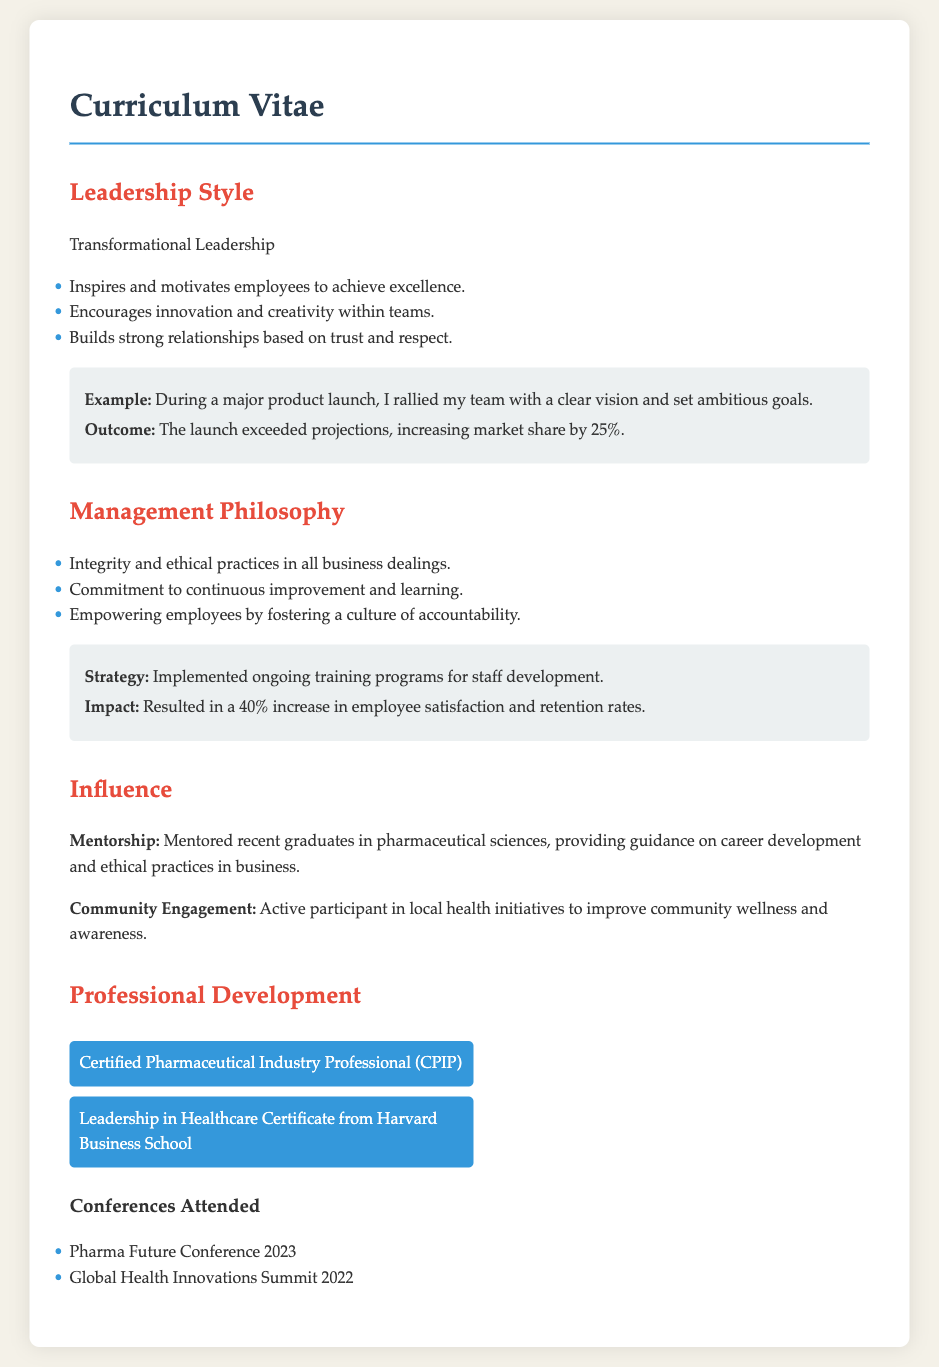What is the leadership style mentioned? The leadership style described is "Transformational Leadership."
Answer: Transformational Leadership What is highlighted as a key outcome of the product launch example? The outcome of the product launch example was a 25% increase in market share.
Answer: 25% What are two components of the management philosophy? The management philosophy includes "Integrity and ethical practices" and "Commitment to continuous improvement."
Answer: Integrity and ethical practices, Commitment to continuous improvement What percentage increase in employee satisfaction resulted from training programs? The training programs led to a 40% increase in employee satisfaction and retention rates.
Answer: 40% Which prestigious institution awarded a certificate in Leadership in Healthcare? The certificate was awarded by Harvard Business School.
Answer: Harvard Business School How many conferences are listed in the document? Two conferences are mentioned in the document.
Answer: 2 What aspect of their work does the individual emphasize in their community engagement? The individual focuses on improving community wellness and awareness.
Answer: Community wellness and awareness What is emphasized as being fundamental in all business dealings? The document emphasizes "Integrity and ethical practices" as fundamental in business dealings.
Answer: Integrity and ethical practices 